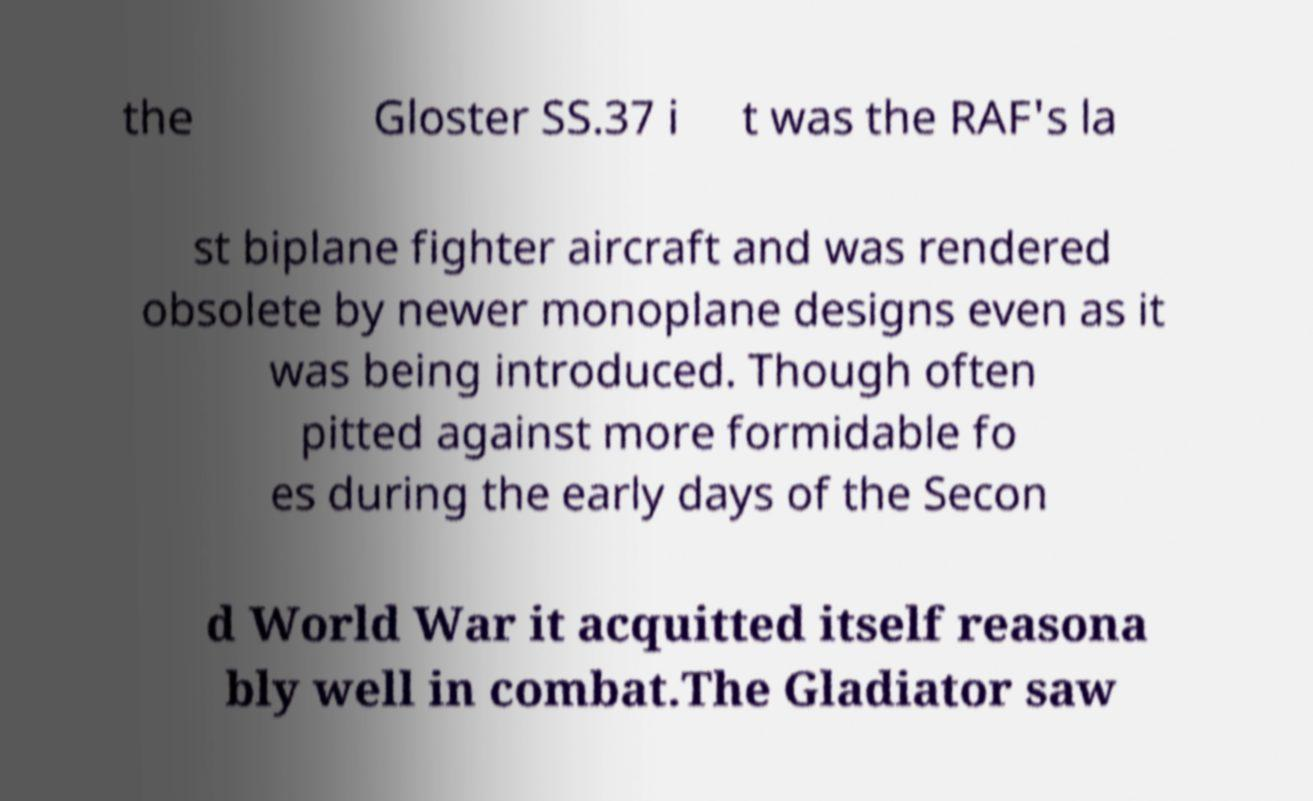I need the written content from this picture converted into text. Can you do that? the Gloster SS.37 i t was the RAF's la st biplane fighter aircraft and was rendered obsolete by newer monoplane designs even as it was being introduced. Though often pitted against more formidable fo es during the early days of the Secon d World War it acquitted itself reasona bly well in combat.The Gladiator saw 